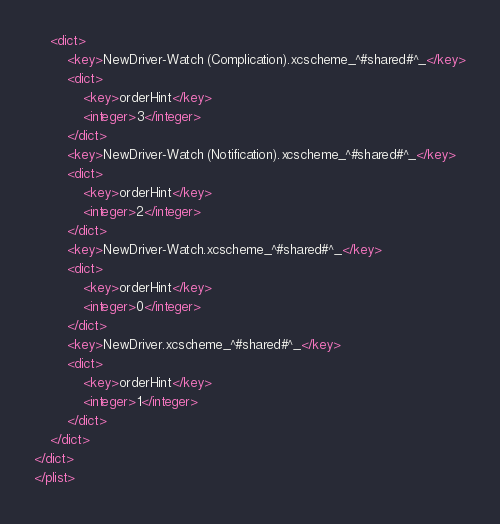<code> <loc_0><loc_0><loc_500><loc_500><_XML_>	<dict>
		<key>NewDriver-Watch (Complication).xcscheme_^#shared#^_</key>
		<dict>
			<key>orderHint</key>
			<integer>3</integer>
		</dict>
		<key>NewDriver-Watch (Notification).xcscheme_^#shared#^_</key>
		<dict>
			<key>orderHint</key>
			<integer>2</integer>
		</dict>
		<key>NewDriver-Watch.xcscheme_^#shared#^_</key>
		<dict>
			<key>orderHint</key>
			<integer>0</integer>
		</dict>
		<key>NewDriver.xcscheme_^#shared#^_</key>
		<dict>
			<key>orderHint</key>
			<integer>1</integer>
		</dict>
	</dict>
</dict>
</plist>
</code> 